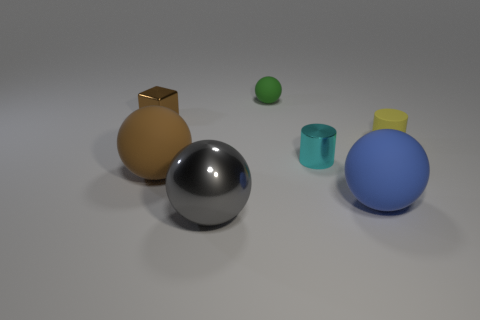What is the material of the brown thing that is the same size as the yellow cylinder?
Offer a terse response. Metal. How many other things are there of the same material as the small green sphere?
Keep it short and to the point. 3. There is a small metal thing that is right of the big ball that is behind the large blue matte sphere; what is its shape?
Provide a succinct answer. Cylinder. What number of objects are brown matte blocks or balls that are to the left of the green matte sphere?
Give a very brief answer. 2. How many other objects are the same color as the metal block?
Give a very brief answer. 1. How many red things are either big objects or cylinders?
Keep it short and to the point. 0. There is a small matte object on the left side of the small thing to the right of the blue rubber sphere; is there a cylinder behind it?
Provide a short and direct response. No. Is the color of the shiny cube the same as the small matte sphere?
Your answer should be very brief. No. There is a big matte sphere that is to the right of the matte sphere that is behind the tiny cyan metal cylinder; what is its color?
Provide a succinct answer. Blue. What number of large objects are blue blocks or cylinders?
Provide a succinct answer. 0. 